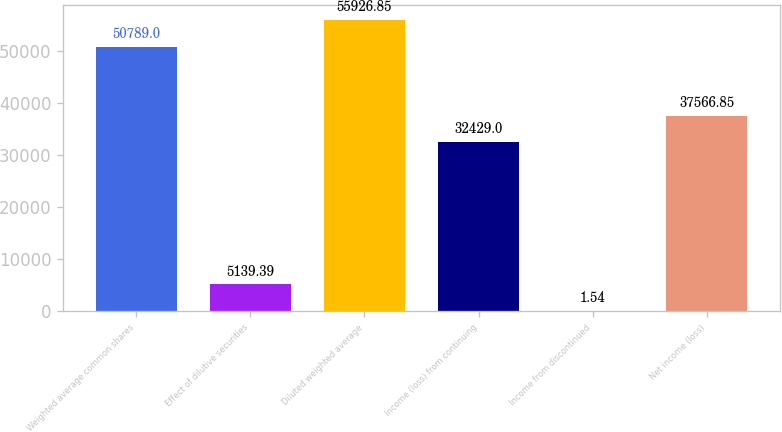Convert chart to OTSL. <chart><loc_0><loc_0><loc_500><loc_500><bar_chart><fcel>Weighted average common shares<fcel>Effect of dilutive securities<fcel>Diluted weighted average<fcel>Income (loss) from continuing<fcel>Income from discontinued<fcel>Net income (loss)<nl><fcel>50789<fcel>5139.39<fcel>55926.8<fcel>32429<fcel>1.54<fcel>37566.8<nl></chart> 